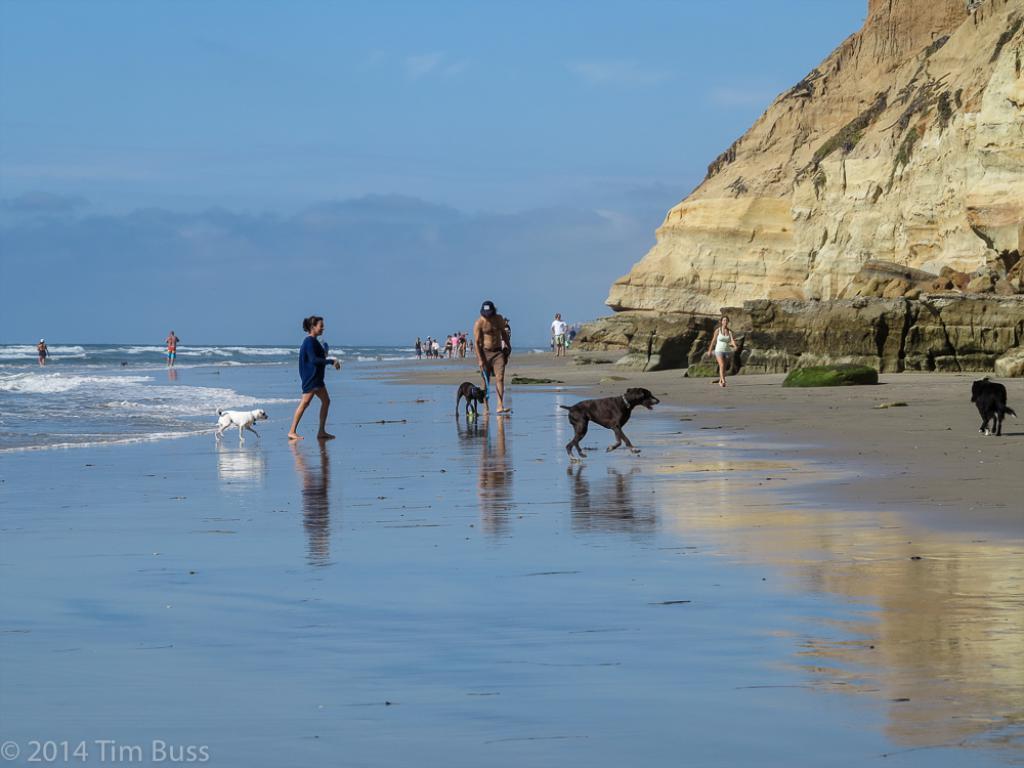Could you give a brief overview of what you see in this image? In this image we can see dogs are running and walking on the sand and we can see few persons are walking on the sand. On the left side we can see water. On the right side we can see a cliff. In the background we can see clouds in the sky. 